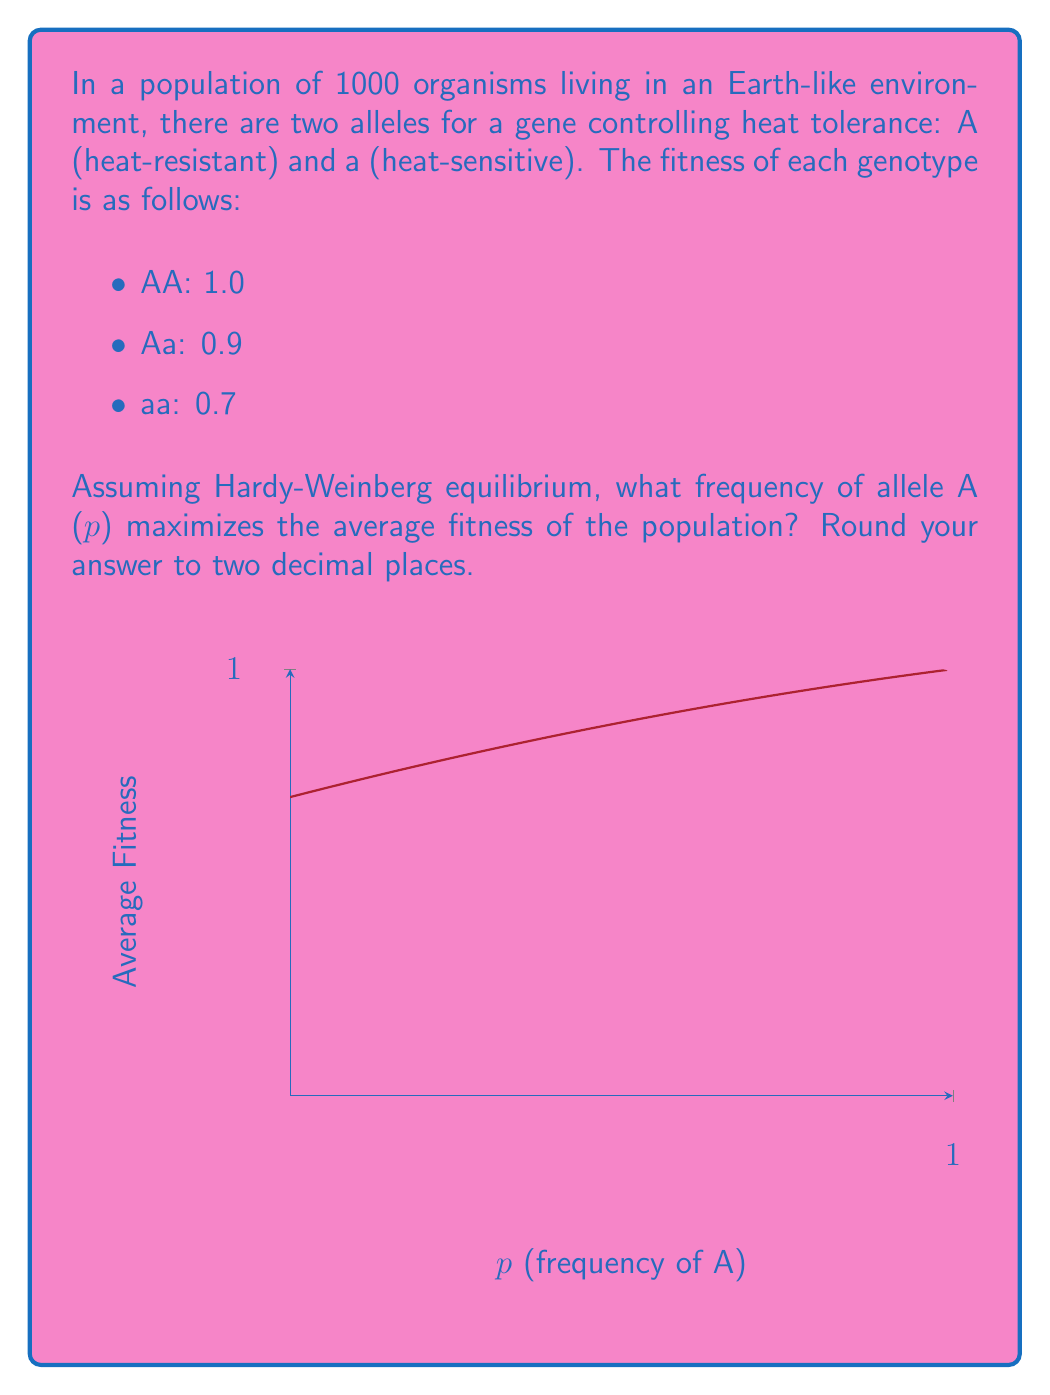Teach me how to tackle this problem. To find the frequency of allele A that maximizes the average fitness, we need to follow these steps:

1) First, let's express the average fitness (W) as a function of p:

   $$W = p^2 + 0.9(2p(1-p)) + 0.7(1-p)^2$$

2) Expand this equation:

   $$W = p^2 + 1.8p - 1.8p^2 + 0.7 - 1.4p + 0.7p^2$$

3) Simplify:

   $$W = -0.1p^2 + 0.4p + 0.7$$

4) To find the maximum, we need to differentiate W with respect to p and set it to zero:

   $$\frac{dW}{dp} = -0.2p + 0.4 = 0$$

5) Solve this equation:

   $$-0.2p + 0.4 = 0$$
   $$-0.2p = -0.4$$
   $$p = 2$$

6) Since p is a frequency, it must be between 0 and 1. The value p = 2 is outside this range, so the maximum must occur at one of the endpoints. We need to compare W(0) and W(1):

   W(0) = 0.7
   W(1) = -0.1 + 0.4 + 0.7 = 1.0

7) The maximum occurs at p = 1, which means the population fitness is maximized when all individuals have the AA genotype.
Answer: 1.00 